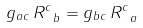Convert formula to latex. <formula><loc_0><loc_0><loc_500><loc_500>g _ { a c } \, R ^ { c } _ { \ b } = g _ { b c } \, R ^ { c } _ { \ a } \,</formula> 